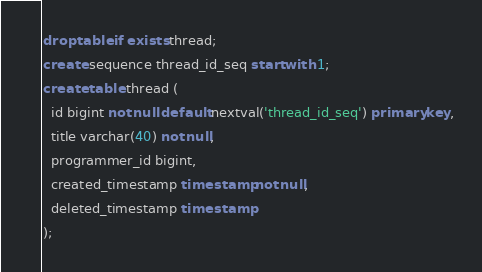<code> <loc_0><loc_0><loc_500><loc_500><_SQL_>drop table if exists thread;
create sequence thread_id_seq start with 1;
create table thread (
  id bigint not null default nextval('thread_id_seq') primary key,
  title varchar(40) not null,
  programmer_id bigint,
  created_timestamp timestamp not null,
  deleted_timestamp timestamp
);
</code> 